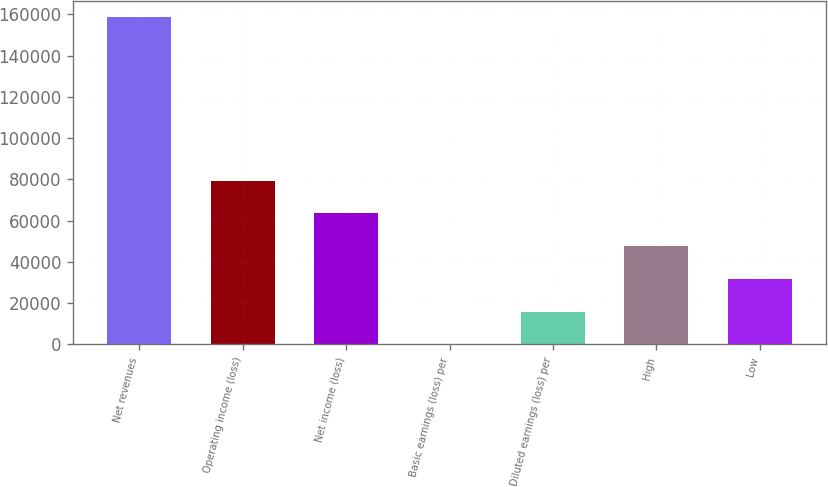<chart> <loc_0><loc_0><loc_500><loc_500><bar_chart><fcel>Net revenues<fcel>Operating income (loss)<fcel>Net income (loss)<fcel>Basic earnings (loss) per<fcel>Diluted earnings (loss) per<fcel>High<fcel>Low<nl><fcel>158725<fcel>79362.5<fcel>63490<fcel>0.03<fcel>15872.5<fcel>47617.5<fcel>31745<nl></chart> 